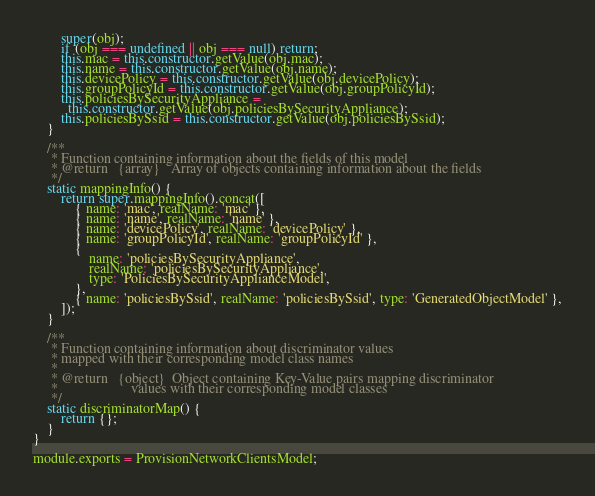<code> <loc_0><loc_0><loc_500><loc_500><_JavaScript_>        super(obj);
        if (obj === undefined || obj === null) return;
        this.mac = this.constructor.getValue(obj.mac);
        this.name = this.constructor.getValue(obj.name);
        this.devicePolicy = this.constructor.getValue(obj.devicePolicy);
        this.groupPolicyId = this.constructor.getValue(obj.groupPolicyId);
        this.policiesBySecurityAppliance =
          this.constructor.getValue(obj.policiesBySecurityAppliance);
        this.policiesBySsid = this.constructor.getValue(obj.policiesBySsid);
    }

    /**
     * Function containing information about the fields of this model
     * @return   {array}   Array of objects containing information about the fields
     */
    static mappingInfo() {
        return super.mappingInfo().concat([
            { name: 'mac', realName: 'mac' },
            { name: 'name', realName: 'name' },
            { name: 'devicePolicy', realName: 'devicePolicy' },
            { name: 'groupPolicyId', realName: 'groupPolicyId' },
            {
                name: 'policiesBySecurityAppliance',
                realName: 'policiesBySecurityAppliance',
                type: 'PoliciesBySecurityApplianceModel',
            },
            { name: 'policiesBySsid', realName: 'policiesBySsid', type: 'GeneratedObjectModel' },
        ]);
    }

    /**
     * Function containing information about discriminator values
     * mapped with their corresponding model class names
     *
     * @return   {object}  Object containing Key-Value pairs mapping discriminator
     *                     values with their corresponding model classes
     */
    static discriminatorMap() {
        return {};
    }
}

module.exports = ProvisionNetworkClientsModel;
</code> 